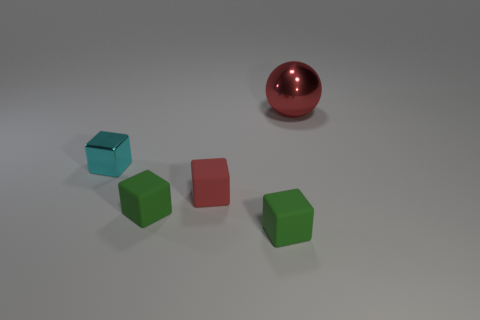Is there anything else of the same color as the small metal cube?
Give a very brief answer. No. There is a big metal thing that is on the right side of the green matte block that is on the right side of the red rubber block; what color is it?
Your response must be concise. Red. Is there a big gray cylinder?
Offer a very short reply. No. There is a thing that is both behind the small red rubber block and in front of the red shiny sphere; what is its color?
Offer a terse response. Cyan. There is a red object that is behind the cyan shiny block; is its size the same as the green object on the left side of the red matte object?
Your answer should be compact. No. What number of other things are the same size as the red sphere?
Your answer should be very brief. 0. There is a shiny thing that is right of the cyan object; what number of cyan metallic things are behind it?
Your answer should be very brief. 0. Is the number of red blocks on the right side of the tiny red cube less than the number of rubber objects?
Keep it short and to the point. Yes. What shape is the cyan metallic thing behind the red object that is in front of the red object that is behind the small cyan metallic object?
Keep it short and to the point. Cube. Is the red matte object the same shape as the small cyan thing?
Your answer should be compact. Yes. 